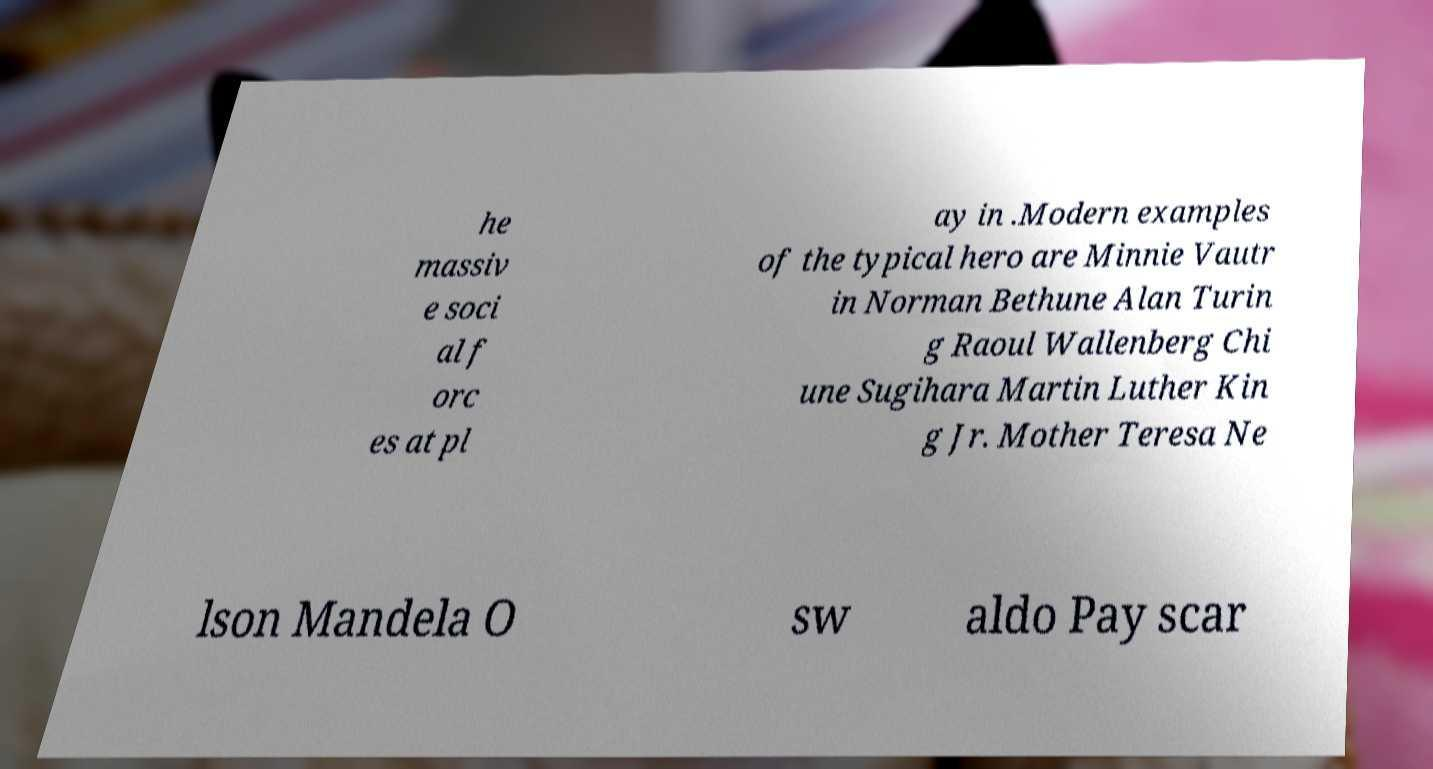Please read and relay the text visible in this image. What does it say? he massiv e soci al f orc es at pl ay in .Modern examples of the typical hero are Minnie Vautr in Norman Bethune Alan Turin g Raoul Wallenberg Chi une Sugihara Martin Luther Kin g Jr. Mother Teresa Ne lson Mandela O sw aldo Pay scar 